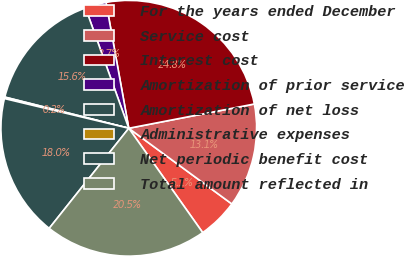Convert chart to OTSL. <chart><loc_0><loc_0><loc_500><loc_500><pie_chart><fcel>For the years ended December<fcel>Service cost<fcel>Interest cost<fcel>Amortization of prior service<fcel>Amortization of net loss<fcel>Administrative expenses<fcel>Net periodic benefit cost<fcel>Total amount reflected in<nl><fcel>5.11%<fcel>13.12%<fcel>24.81%<fcel>2.65%<fcel>15.58%<fcel>0.19%<fcel>18.04%<fcel>20.5%<nl></chart> 